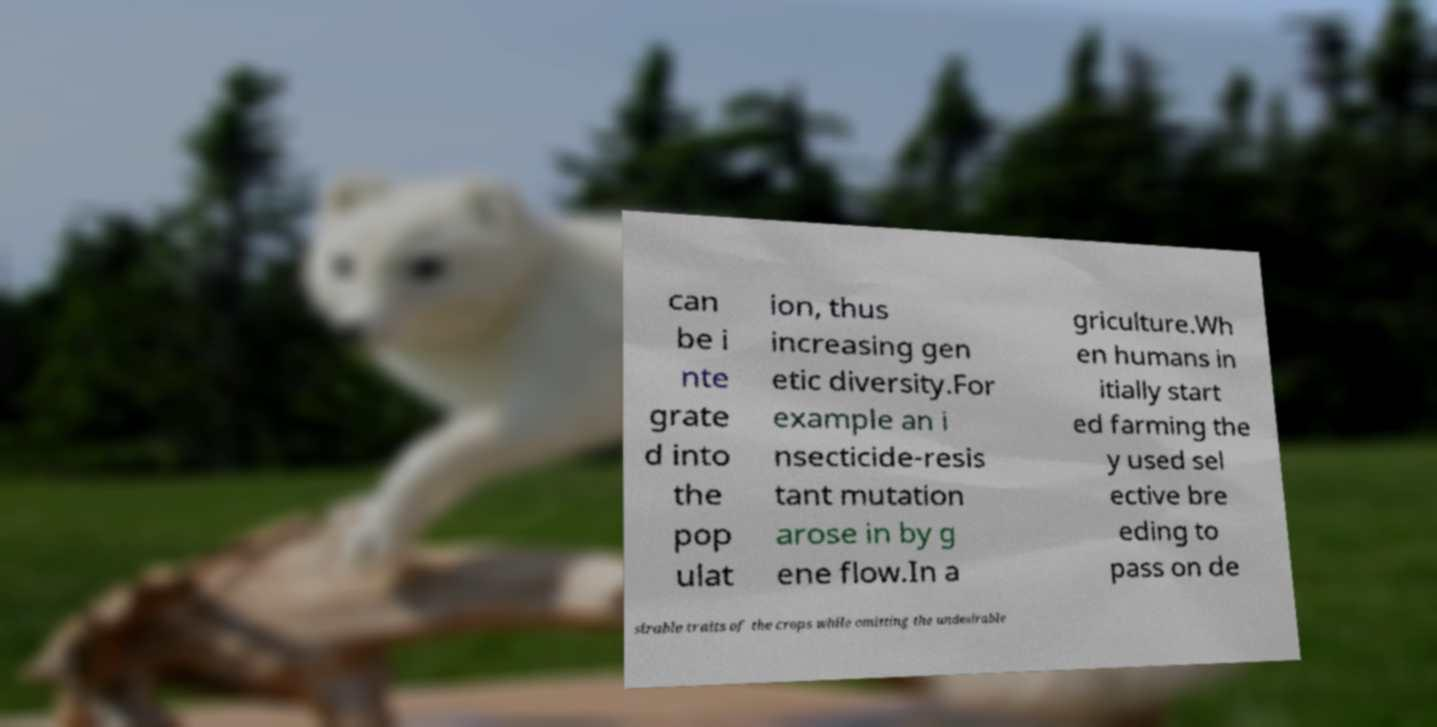What messages or text are displayed in this image? I need them in a readable, typed format. can be i nte grate d into the pop ulat ion, thus increasing gen etic diversity.For example an i nsecticide-resis tant mutation arose in by g ene flow.In a griculture.Wh en humans in itially start ed farming the y used sel ective bre eding to pass on de sirable traits of the crops while omitting the undesirable 